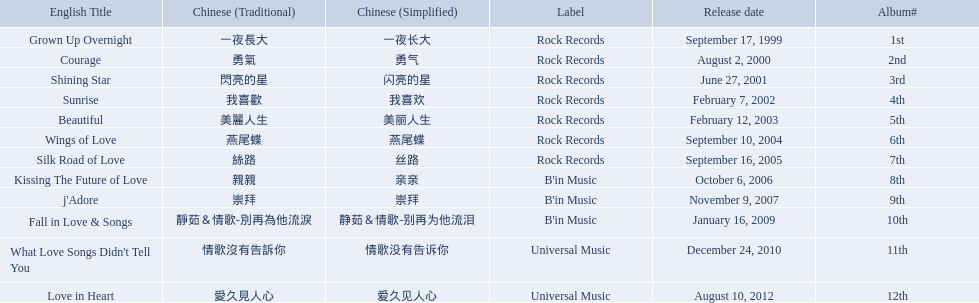What were the albums? Grown Up Overnight, Courage, Shining Star, Sunrise, Beautiful, Wings of Love, Silk Road of Love, Kissing The Future of Love, j'Adore, Fall in Love & Songs, What Love Songs Didn't Tell You, Love in Heart. Which ones were released by b'in music? Kissing The Future of Love, j'Adore. Of these, which one was in an even-numbered year? Kissing The Future of Love. 